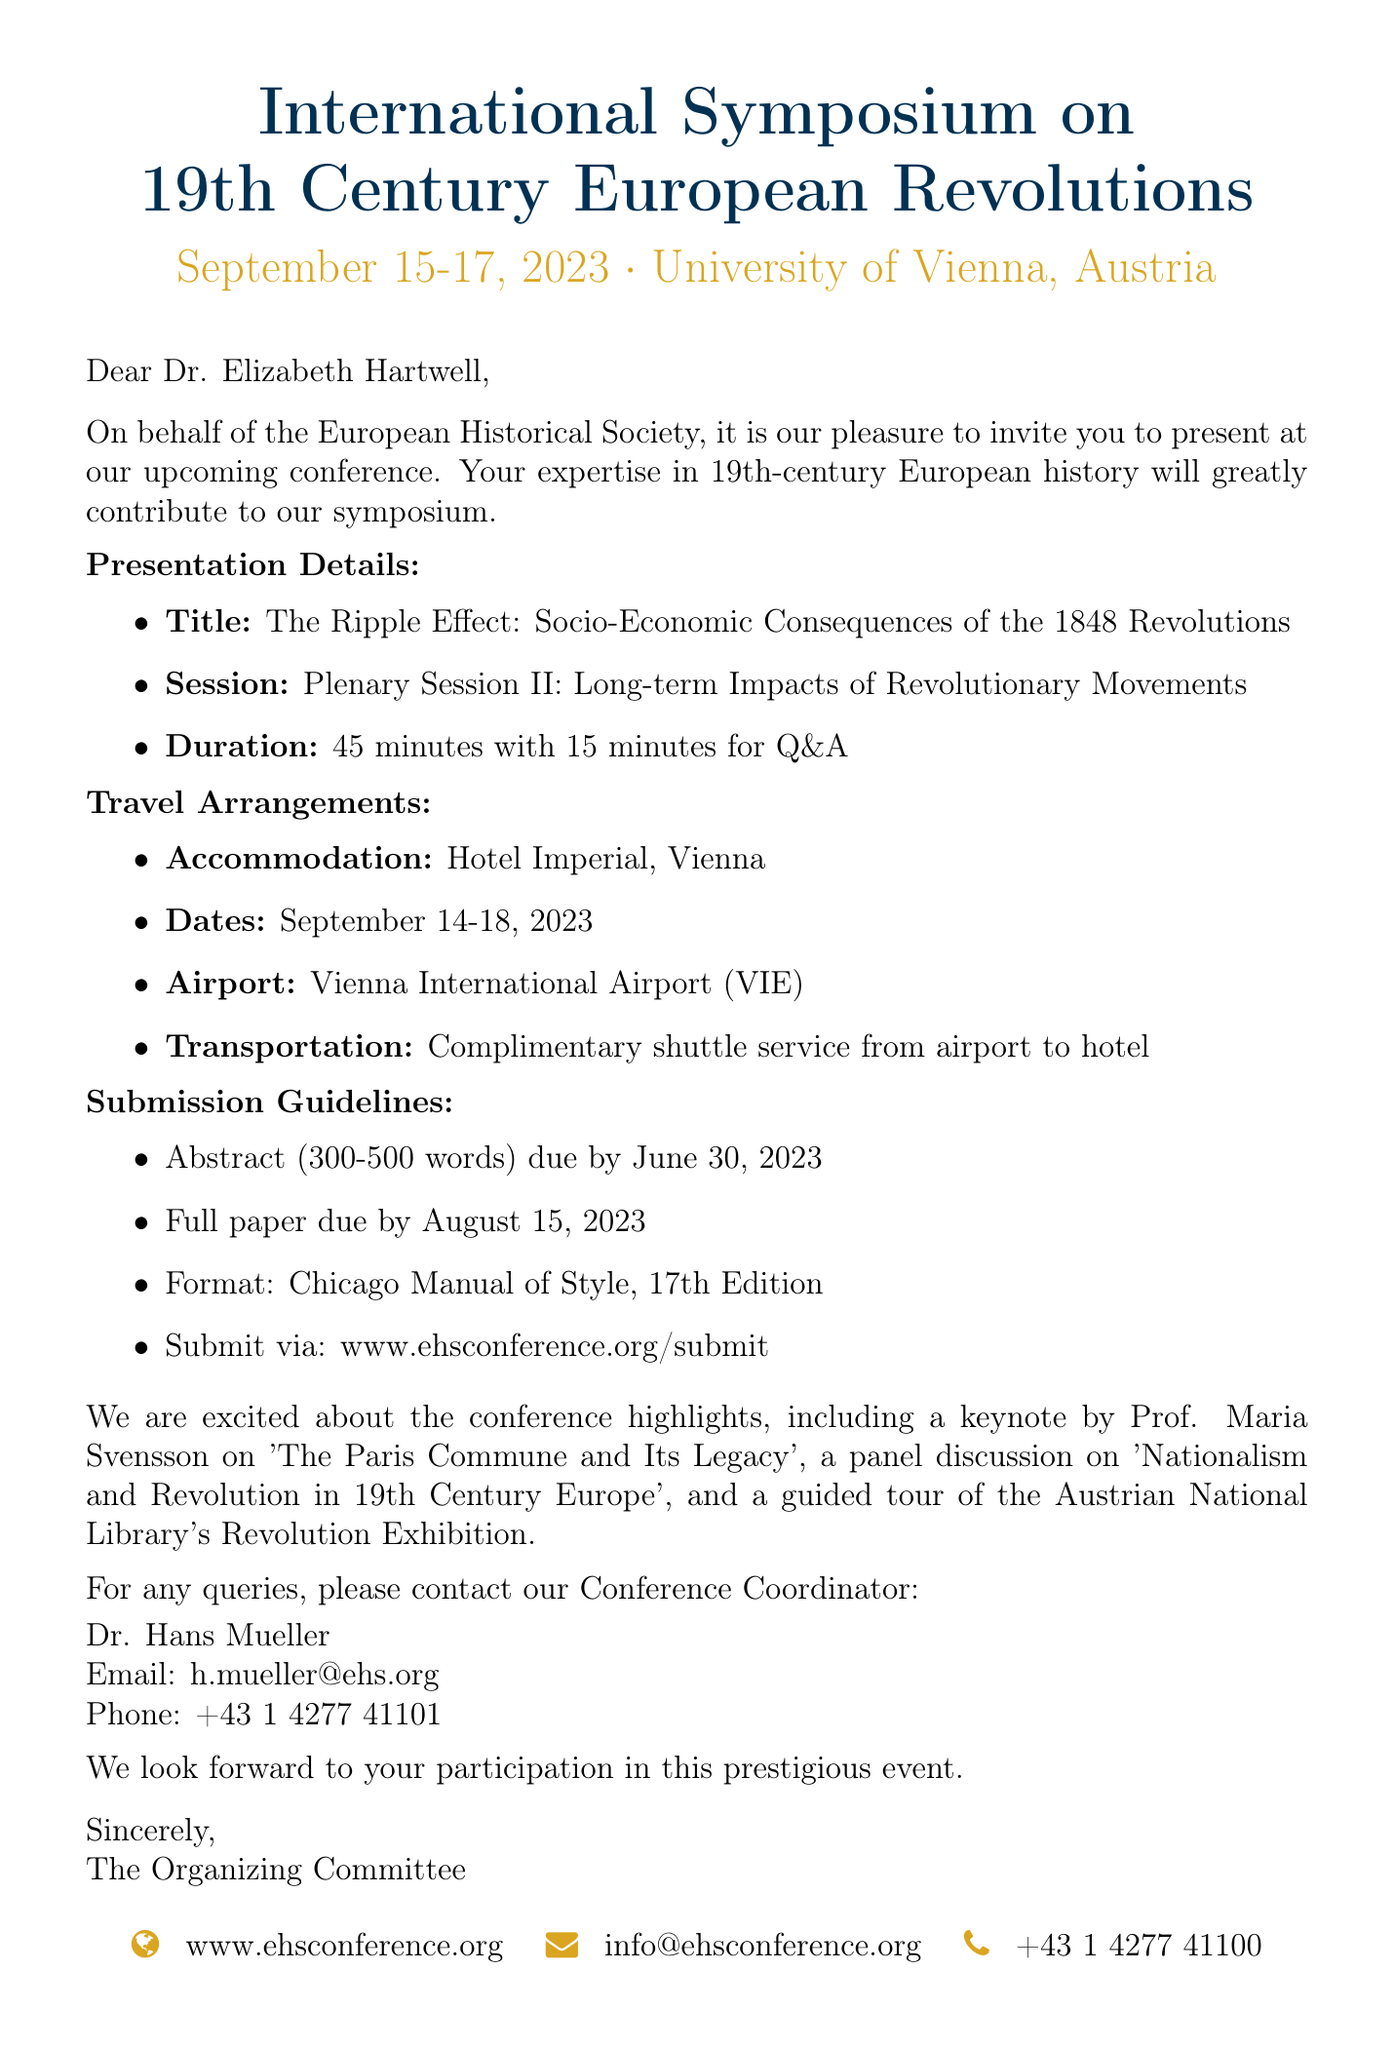What are the dates of the conference? The conference dates are explicitly mentioned in the document as September 15-17, 2023.
Answer: September 15-17, 2023 What is the title of the invited presentation? The document states that the presentation title is "The Ripple Effect: Socio-Economic Consequences of the 1848 Revolutions".
Answer: The Ripple Effect: Socio-Economic Consequences of the 1848 Revolutions Who is the contact person for the conference? The email provides the name of the contact person as Dr. Hans Mueller, who is the Conference Coordinator.
Answer: Dr. Hans Mueller What is the paper format required for submission? The document specifies that the paper format should follow the Chicago Manual of Style, 17th Edition.
Answer: Chicago Manual of Style, 17th Edition What accommodation is provided for the invited speaker? The travel arrangements section of the document indicates that accommodation will be at Hotel Imperial, Vienna.
Answer: Hotel Imperial, Vienna What is the duration of the presentation? The duration is clearly stated in the document as 45 minutes with 15 minutes for Q&A.
Answer: 45 minutes with 15 minutes for Q&A What is the website for paper submission? The submission guidelines in the document include the URL for the submission portal as www.ehsconference.org/submit.
Answer: www.ehsconference.org/submit What type of event is being organized? The email refers to it as the International Symposium on 19th Century European Revolutions, indicating it is an academic conference.
Answer: International Symposium on 19th Century European Revolutions 